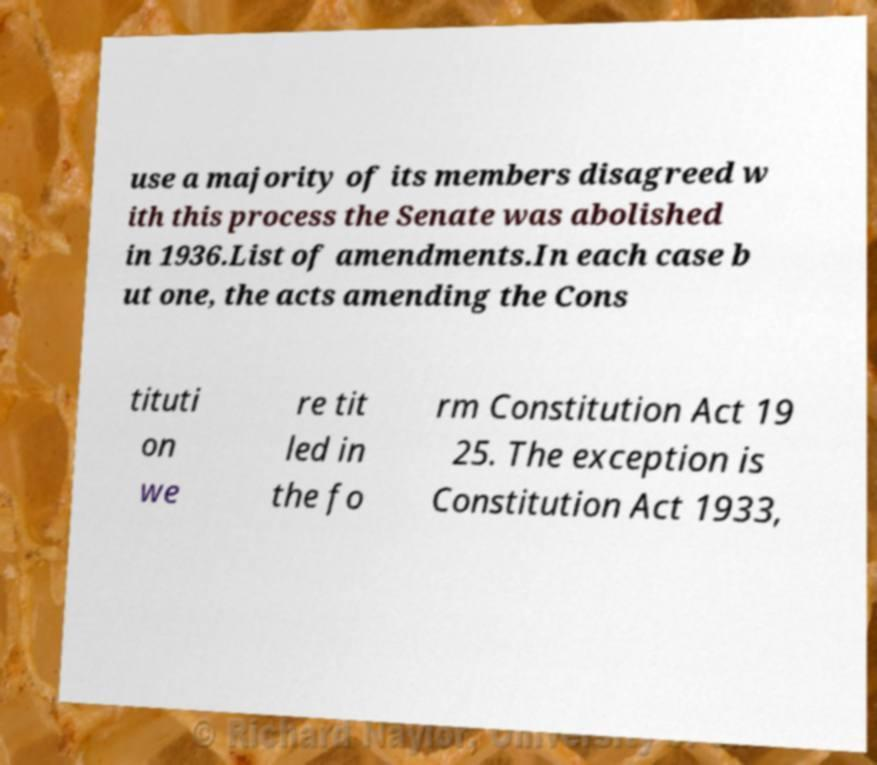Could you extract and type out the text from this image? use a majority of its members disagreed w ith this process the Senate was abolished in 1936.List of amendments.In each case b ut one, the acts amending the Cons tituti on we re tit led in the fo rm Constitution Act 19 25. The exception is Constitution Act 1933, 